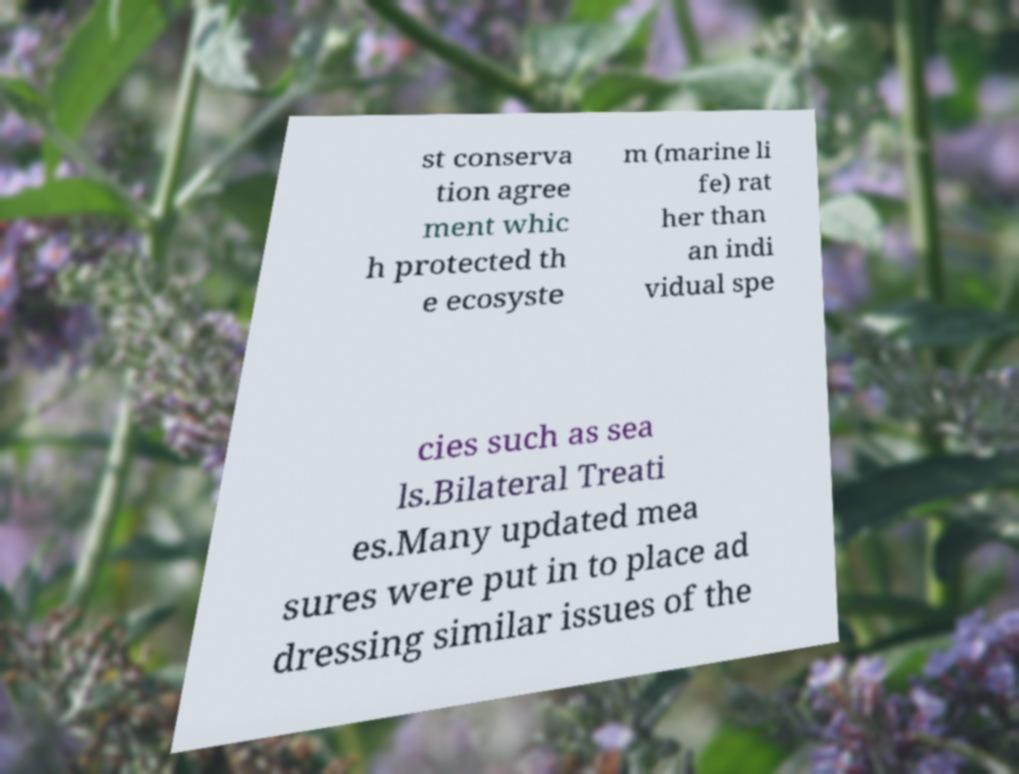There's text embedded in this image that I need extracted. Can you transcribe it verbatim? st conserva tion agree ment whic h protected th e ecosyste m (marine li fe) rat her than an indi vidual spe cies such as sea ls.Bilateral Treati es.Many updated mea sures were put in to place ad dressing similar issues of the 